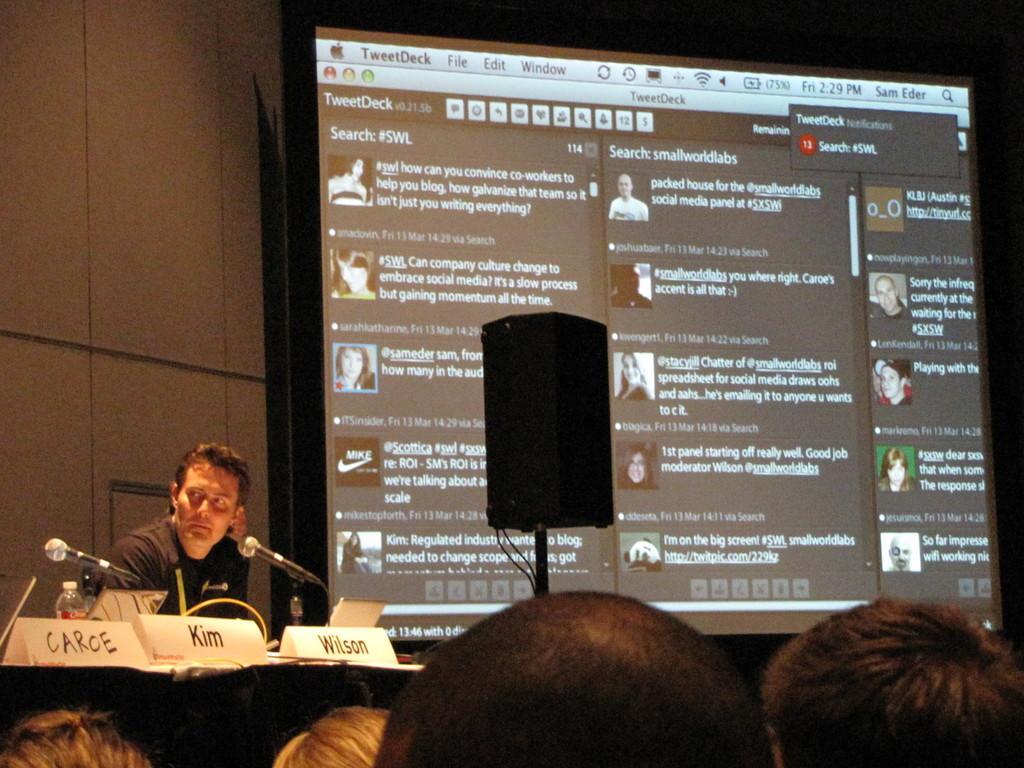How would you summarize this image in a sentence or two? In this image we can see a person sitting. In front of him there are mice, bottles and name boards. At the bottom we can see heads of persons. In the background there is a screen with some text and images. In the background there is a wall. 